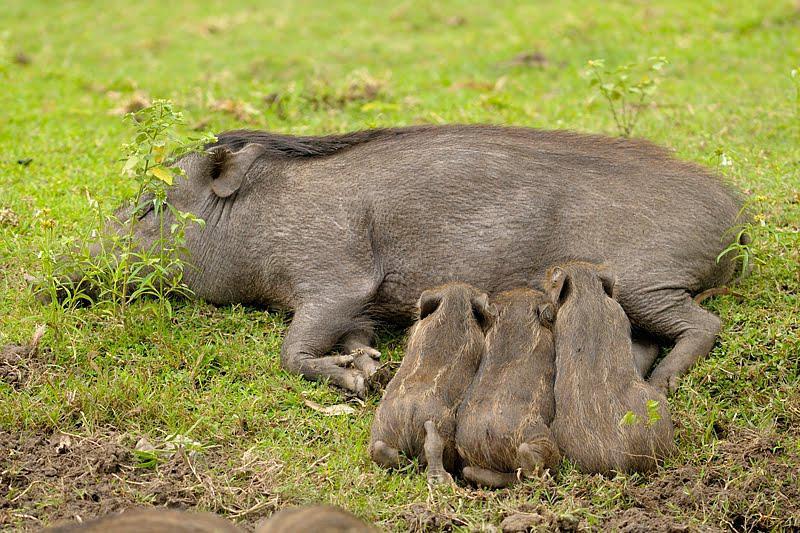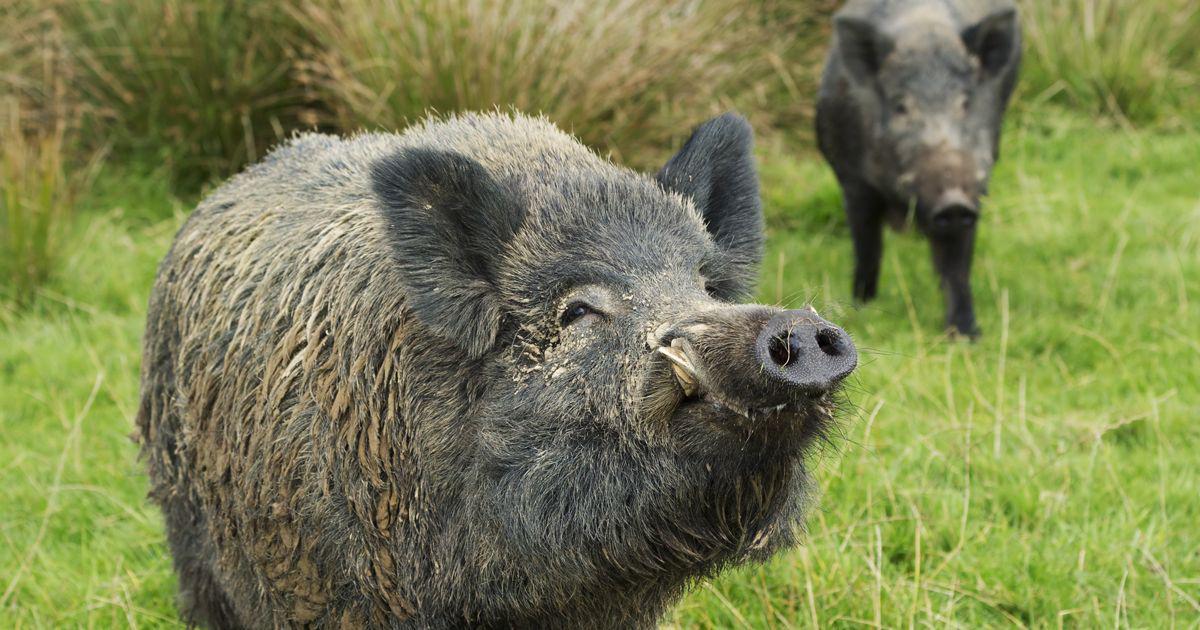The first image is the image on the left, the second image is the image on the right. Examine the images to the left and right. Is the description "One image shows a single wild pig with its head and body facing forward, and the other image shows a single standing wild pig with its head and body in profile." accurate? Answer yes or no. No. The first image is the image on the left, the second image is the image on the right. Evaluate the accuracy of this statement regarding the images: "The pig in the image on the left is facing the camera.". Is it true? Answer yes or no. No. 